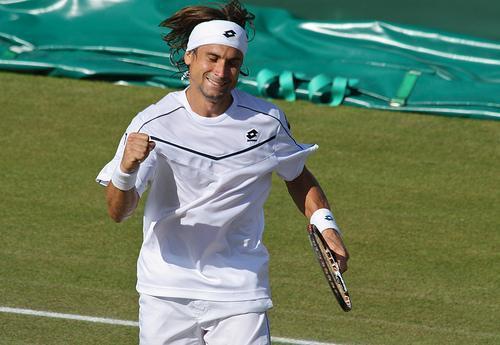How many are bands is the man wearing?
Give a very brief answer. 2. 